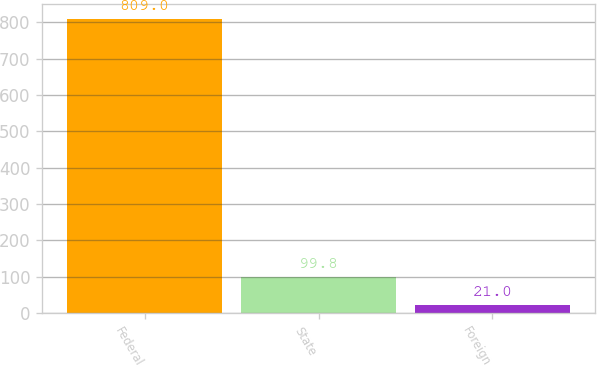Convert chart to OTSL. <chart><loc_0><loc_0><loc_500><loc_500><bar_chart><fcel>Federal<fcel>State<fcel>Foreign<nl><fcel>809<fcel>99.8<fcel>21<nl></chart> 